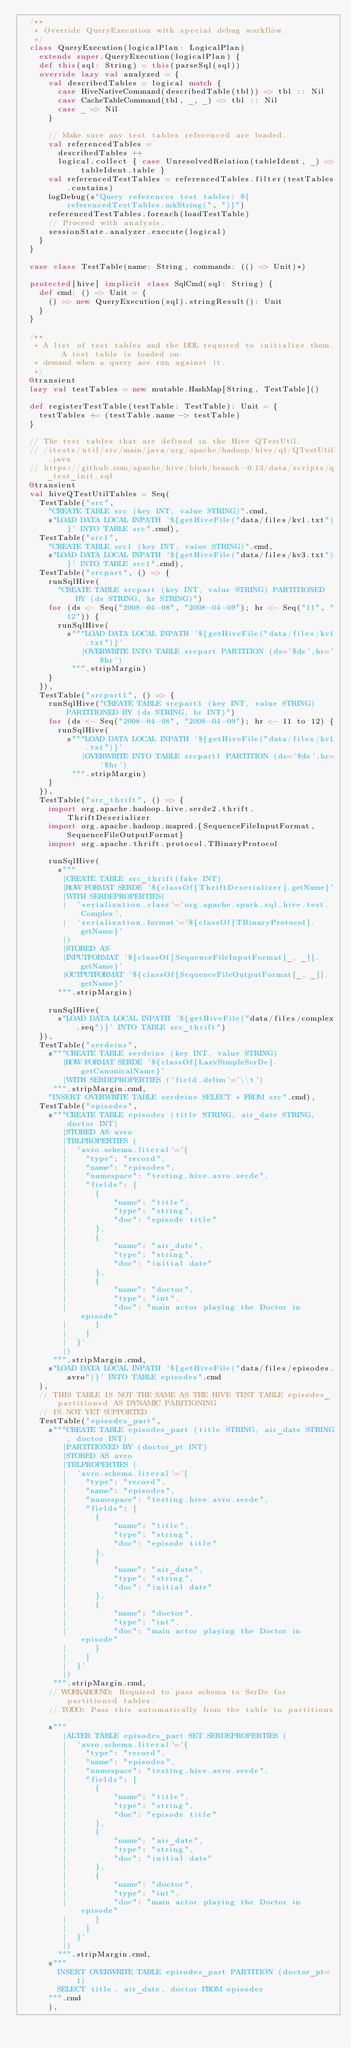<code> <loc_0><loc_0><loc_500><loc_500><_Scala_>  /**
   * Override QueryExecution with special debug workflow.
   */
  class QueryExecution(logicalPlan: LogicalPlan)
    extends super.QueryExecution(logicalPlan) {
    def this(sql: String) = this(parseSql(sql))
    override lazy val analyzed = {
      val describedTables = logical match {
        case HiveNativeCommand(describedTable(tbl)) => tbl :: Nil
        case CacheTableCommand(tbl, _, _) => tbl :: Nil
        case _ => Nil
      }

      // Make sure any test tables referenced are loaded.
      val referencedTables =
        describedTables ++
        logical.collect { case UnresolvedRelation(tableIdent, _) => tableIdent.table }
      val referencedTestTables = referencedTables.filter(testTables.contains)
      logDebug(s"Query references test tables: ${referencedTestTables.mkString(", ")}")
      referencedTestTables.foreach(loadTestTable)
      // Proceed with analysis.
      sessionState.analyzer.execute(logical)
    }
  }

  case class TestTable(name: String, commands: (() => Unit)*)

  protected[hive] implicit class SqlCmd(sql: String) {
    def cmd: () => Unit = {
      () => new QueryExecution(sql).stringResult(): Unit
    }
  }

  /**
   * A list of test tables and the DDL required to initialize them.  A test table is loaded on
   * demand when a query are run against it.
   */
  @transient
  lazy val testTables = new mutable.HashMap[String, TestTable]()

  def registerTestTable(testTable: TestTable): Unit = {
    testTables += (testTable.name -> testTable)
  }

  // The test tables that are defined in the Hive QTestUtil.
  // /itests/util/src/main/java/org/apache/hadoop/hive/ql/QTestUtil.java
  // https://github.com/apache/hive/blob/branch-0.13/data/scripts/q_test_init.sql
  @transient
  val hiveQTestUtilTables = Seq(
    TestTable("src",
      "CREATE TABLE src (key INT, value STRING)".cmd,
      s"LOAD DATA LOCAL INPATH '${getHiveFile("data/files/kv1.txt")}' INTO TABLE src".cmd),
    TestTable("src1",
      "CREATE TABLE src1 (key INT, value STRING)".cmd,
      s"LOAD DATA LOCAL INPATH '${getHiveFile("data/files/kv3.txt")}' INTO TABLE src1".cmd),
    TestTable("srcpart", () => {
      runSqlHive(
        "CREATE TABLE srcpart (key INT, value STRING) PARTITIONED BY (ds STRING, hr STRING)")
      for (ds <- Seq("2008-04-08", "2008-04-09"); hr <- Seq("11", "12")) {
        runSqlHive(
          s"""LOAD DATA LOCAL INPATH '${getHiveFile("data/files/kv1.txt")}'
             |OVERWRITE INTO TABLE srcpart PARTITION (ds='$ds',hr='$hr')
           """.stripMargin)
      }
    }),
    TestTable("srcpart1", () => {
      runSqlHive("CREATE TABLE srcpart1 (key INT, value STRING) PARTITIONED BY (ds STRING, hr INT)")
      for (ds <- Seq("2008-04-08", "2008-04-09"); hr <- 11 to 12) {
        runSqlHive(
          s"""LOAD DATA LOCAL INPATH '${getHiveFile("data/files/kv1.txt")}'
             |OVERWRITE INTO TABLE srcpart1 PARTITION (ds='$ds',hr='$hr')
           """.stripMargin)
      }
    }),
    TestTable("src_thrift", () => {
      import org.apache.hadoop.hive.serde2.thrift.ThriftDeserializer
      import org.apache.hadoop.mapred.{SequenceFileInputFormat, SequenceFileOutputFormat}
      import org.apache.thrift.protocol.TBinaryProtocol

      runSqlHive(
        s"""
         |CREATE TABLE src_thrift(fake INT)
         |ROW FORMAT SERDE '${classOf[ThriftDeserializer].getName}'
         |WITH SERDEPROPERTIES(
         |  'serialization.class'='org.apache.spark.sql.hive.test.Complex',
         |  'serialization.format'='${classOf[TBinaryProtocol].getName}'
         |)
         |STORED AS
         |INPUTFORMAT '${classOf[SequenceFileInputFormat[_, _]].getName}'
         |OUTPUTFORMAT '${classOf[SequenceFileOutputFormat[_, _]].getName}'
        """.stripMargin)

      runSqlHive(
        s"LOAD DATA LOCAL INPATH '${getHiveFile("data/files/complex.seq")}' INTO TABLE src_thrift")
    }),
    TestTable("serdeins",
      s"""CREATE TABLE serdeins (key INT, value STRING)
         |ROW FORMAT SERDE '${classOf[LazySimpleSerDe].getCanonicalName}'
         |WITH SERDEPROPERTIES ('field.delim'='\\t')
       """.stripMargin.cmd,
      "INSERT OVERWRITE TABLE serdeins SELECT * FROM src".cmd),
    TestTable("episodes",
      s"""CREATE TABLE episodes (title STRING, air_date STRING, doctor INT)
         |STORED AS avro
         |TBLPROPERTIES (
         |  'avro.schema.literal'='{
         |    "type": "record",
         |    "name": "episodes",
         |    "namespace": "testing.hive.avro.serde",
         |    "fields": [
         |      {
         |          "name": "title",
         |          "type": "string",
         |          "doc": "episode title"
         |      },
         |      {
         |          "name": "air_date",
         |          "type": "string",
         |          "doc": "initial date"
         |      },
         |      {
         |          "name": "doctor",
         |          "type": "int",
         |          "doc": "main actor playing the Doctor in episode"
         |      }
         |    ]
         |  }'
         |)
       """.stripMargin.cmd,
      s"LOAD DATA LOCAL INPATH '${getHiveFile("data/files/episodes.avro")}' INTO TABLE episodes".cmd
    ),
    // THIS TABLE IS NOT THE SAME AS THE HIVE TEST TABLE episodes_partitioned AS DYNAMIC PARITIONING
    // IS NOT YET SUPPORTED
    TestTable("episodes_part",
      s"""CREATE TABLE episodes_part (title STRING, air_date STRING, doctor INT)
         |PARTITIONED BY (doctor_pt INT)
         |STORED AS avro
         |TBLPROPERTIES (
         |  'avro.schema.literal'='{
         |    "type": "record",
         |    "name": "episodes",
         |    "namespace": "testing.hive.avro.serde",
         |    "fields": [
         |      {
         |          "name": "title",
         |          "type": "string",
         |          "doc": "episode title"
         |      },
         |      {
         |          "name": "air_date",
         |          "type": "string",
         |          "doc": "initial date"
         |      },
         |      {
         |          "name": "doctor",
         |          "type": "int",
         |          "doc": "main actor playing the Doctor in episode"
         |      }
         |    ]
         |  }'
         |)
       """.stripMargin.cmd,
      // WORKAROUND: Required to pass schema to SerDe for partitioned tables.
      // TODO: Pass this automatically from the table to partitions.
      s"""
         |ALTER TABLE episodes_part SET SERDEPROPERTIES (
         |  'avro.schema.literal'='{
         |    "type": "record",
         |    "name": "episodes",
         |    "namespace": "testing.hive.avro.serde",
         |    "fields": [
         |      {
         |          "name": "title",
         |          "type": "string",
         |          "doc": "episode title"
         |      },
         |      {
         |          "name": "air_date",
         |          "type": "string",
         |          "doc": "initial date"
         |      },
         |      {
         |          "name": "doctor",
         |          "type": "int",
         |          "doc": "main actor playing the Doctor in episode"
         |      }
         |    ]
         |  }'
         |)
        """.stripMargin.cmd,
      s"""
        INSERT OVERWRITE TABLE episodes_part PARTITION (doctor_pt=1)
        SELECT title, air_date, doctor FROM episodes
      """.cmd
      ),</code> 